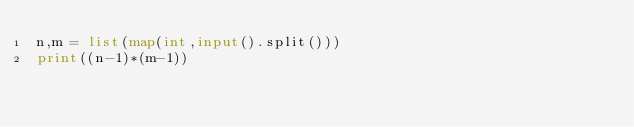<code> <loc_0><loc_0><loc_500><loc_500><_Python_>n,m = list(map(int,input().split()))
print((n-1)*(m-1))</code> 